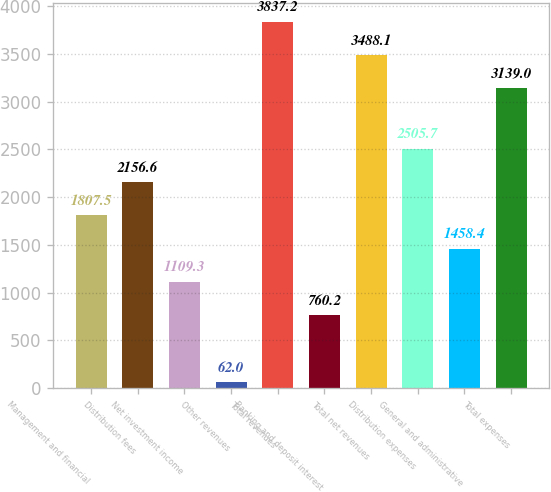<chart> <loc_0><loc_0><loc_500><loc_500><bar_chart><fcel>Management and financial<fcel>Distribution fees<fcel>Net investment income<fcel>Other revenues<fcel>Total revenues<fcel>Banking and deposit interest<fcel>Total net revenues<fcel>Distribution expenses<fcel>General and administrative<fcel>Total expenses<nl><fcel>1807.5<fcel>2156.6<fcel>1109.3<fcel>62<fcel>3837.2<fcel>760.2<fcel>3488.1<fcel>2505.7<fcel>1458.4<fcel>3139<nl></chart> 